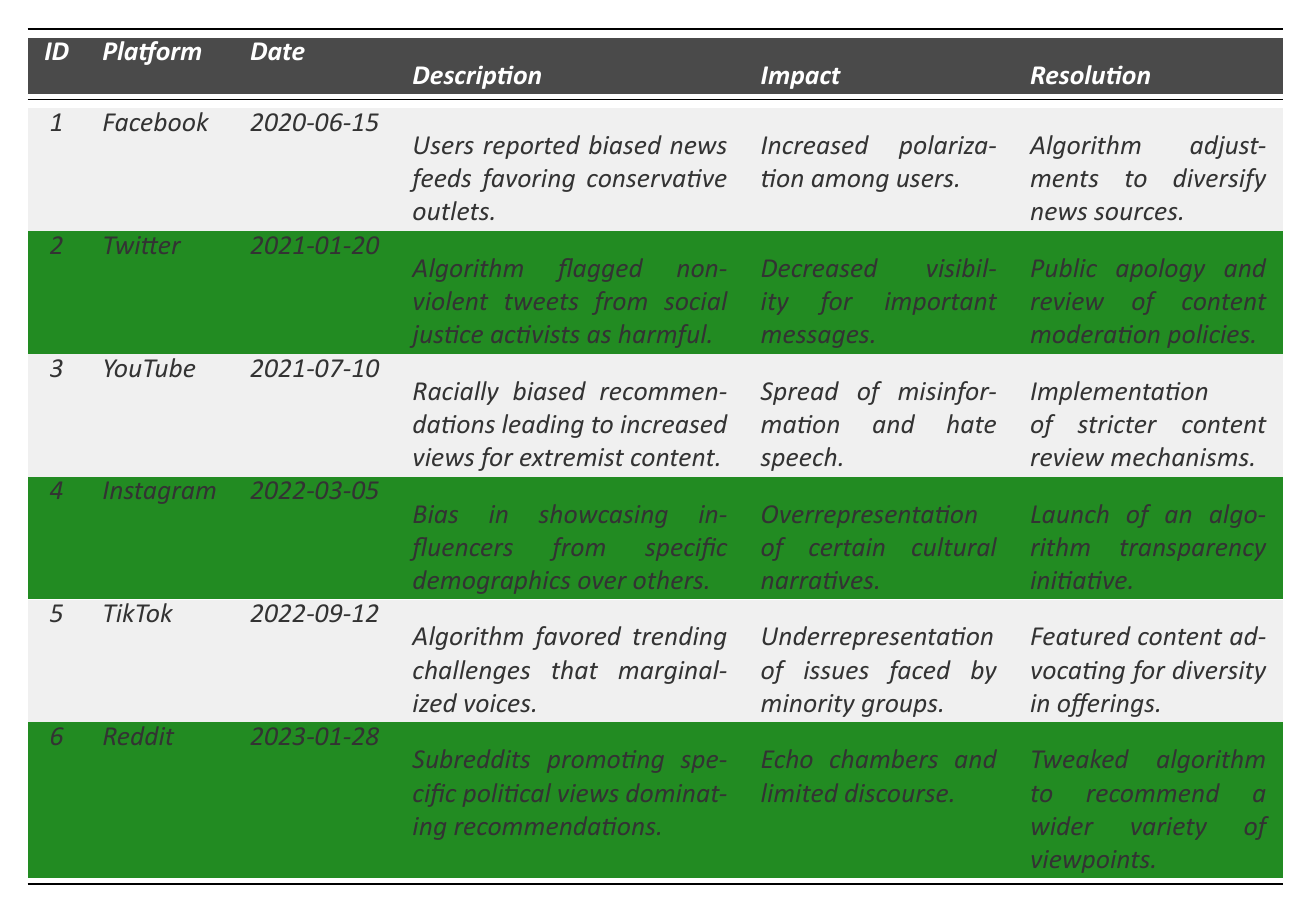What incident occurred on Twitter? The table indicates that on January 20, 2021, Twitter experienced an incident where the algorithm flagged non-violent tweets from social justice activists as harmful.
Answer: Non-violent tweets flagged as harmful What was the resolution for the YouTube incident? According to the table, the resolution for the YouTube incident, which involved racially biased recommendations, was the implementation of stricter content review mechanisms.
Answer: Stricter content review mechanisms Which platform had an incident that led to increased polarization among users? The table shows that the incident on Facebook, reported on June 15, 2020, resulted in increased polarization among users due to biased news feeds favoring conservative outlets.
Answer: Facebook How many incidents were reported in 2022? From the table, there are two incidents reported in 2022—one for Instagram on March 5 and one for TikTok on September 12. Thus, the total is 2.
Answer: 2 Did any incident lead to the launch of an algorithm transparency initiative? The table indicates that the Instagram incident prompted the launch of an algorithm transparency initiative.
Answer: Yes Which platform had incidents involving underrepresentation of minority voices? The incidents on TikTok related to trending challenges marginalized voices, indicating underrepresentation of issues faced by minority groups. TikTok is the platform.
Answer: TikTok Based on the incidents, which platform's algorithm adjustments occurred due to user polarization? The incident description for Facebook mentions adjustments to algorithms designed to diversify news sources in response to increased polarization among users.
Answer: Facebook Which incident had the earliest date and what was its impact? The earliest incident occurred on June 15, 2020, on Facebook, and its impact was increased polarization among users.
Answer: Increased polarization among users What were the impacts of the incidents on Reddit and YouTube? Reddit's incident contributed to echo chambers and limited discourse, while YouTube's led to the spread of misinformation and hate speech. Both have distinct negative impacts outlined in the table.
Answer: Echo chambers for Reddit; misinformation for YouTube Which platforms had algorithm changes as a resolution to incidents? The platforms that had algorithm changes as resolutions include Facebook, TikTok, and Reddit, which all indicated adjustments to their algorithms to address their respective issues.
Answer: Facebook, TikTok, Reddit 